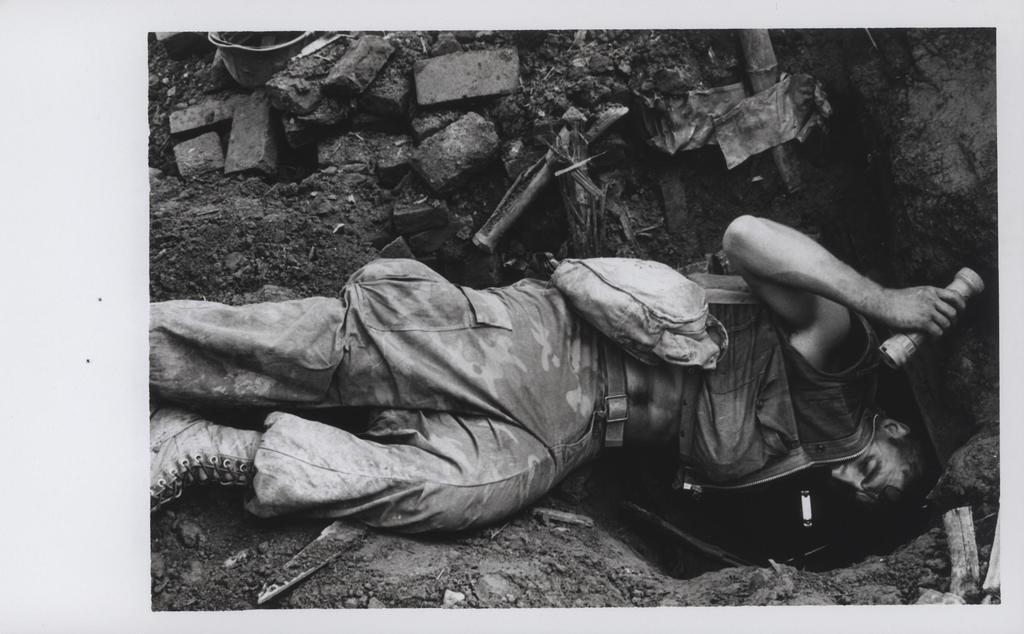Describe this image in one or two sentences. In this image I can see a man is digging the sand, he wore an army dress, shoes. At the bottom there are stones. 